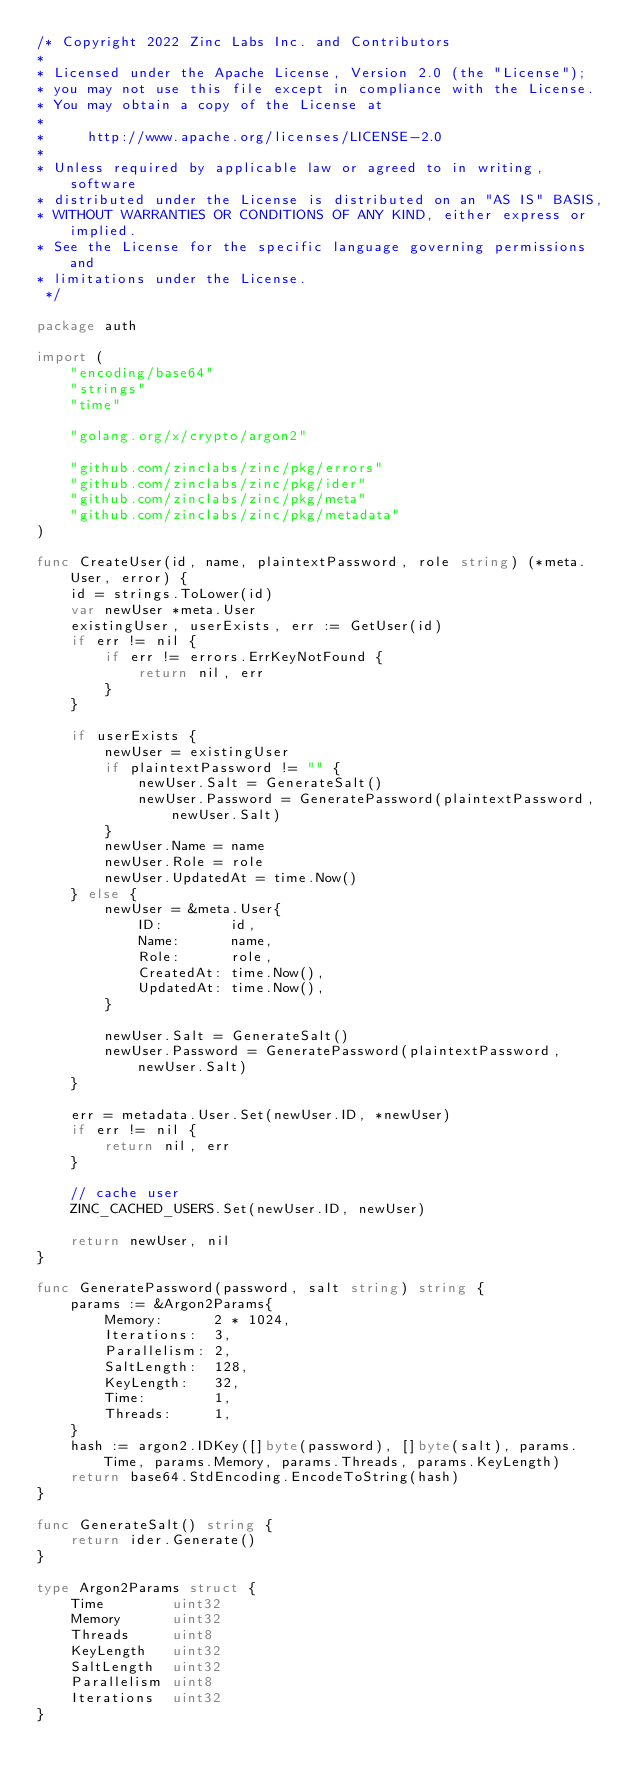Convert code to text. <code><loc_0><loc_0><loc_500><loc_500><_Go_>/* Copyright 2022 Zinc Labs Inc. and Contributors
*
* Licensed under the Apache License, Version 2.0 (the "License");
* you may not use this file except in compliance with the License.
* You may obtain a copy of the License at
*
*     http://www.apache.org/licenses/LICENSE-2.0
*
* Unless required by applicable law or agreed to in writing, software
* distributed under the License is distributed on an "AS IS" BASIS,
* WITHOUT WARRANTIES OR CONDITIONS OF ANY KIND, either express or implied.
* See the License for the specific language governing permissions and
* limitations under the License.
 */

package auth

import (
	"encoding/base64"
	"strings"
	"time"

	"golang.org/x/crypto/argon2"

	"github.com/zinclabs/zinc/pkg/errors"
	"github.com/zinclabs/zinc/pkg/ider"
	"github.com/zinclabs/zinc/pkg/meta"
	"github.com/zinclabs/zinc/pkg/metadata"
)

func CreateUser(id, name, plaintextPassword, role string) (*meta.User, error) {
	id = strings.ToLower(id)
	var newUser *meta.User
	existingUser, userExists, err := GetUser(id)
	if err != nil {
		if err != errors.ErrKeyNotFound {
			return nil, err
		}
	}

	if userExists {
		newUser = existingUser
		if plaintextPassword != "" {
			newUser.Salt = GenerateSalt()
			newUser.Password = GeneratePassword(plaintextPassword, newUser.Salt)
		}
		newUser.Name = name
		newUser.Role = role
		newUser.UpdatedAt = time.Now()
	} else {
		newUser = &meta.User{
			ID:        id,
			Name:      name,
			Role:      role,
			CreatedAt: time.Now(),
			UpdatedAt: time.Now(),
		}

		newUser.Salt = GenerateSalt()
		newUser.Password = GeneratePassword(plaintextPassword, newUser.Salt)
	}

	err = metadata.User.Set(newUser.ID, *newUser)
	if err != nil {
		return nil, err
	}

	// cache user
	ZINC_CACHED_USERS.Set(newUser.ID, newUser)

	return newUser, nil
}

func GeneratePassword(password, salt string) string {
	params := &Argon2Params{
		Memory:      2 * 1024,
		Iterations:  3,
		Parallelism: 2,
		SaltLength:  128,
		KeyLength:   32,
		Time:        1,
		Threads:     1,
	}
	hash := argon2.IDKey([]byte(password), []byte(salt), params.Time, params.Memory, params.Threads, params.KeyLength)
	return base64.StdEncoding.EncodeToString(hash)
}

func GenerateSalt() string {
	return ider.Generate()
}

type Argon2Params struct {
	Time        uint32
	Memory      uint32
	Threads     uint8
	KeyLength   uint32
	SaltLength  uint32
	Parallelism uint8
	Iterations  uint32
}
</code> 